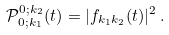Convert formula to latex. <formula><loc_0><loc_0><loc_500><loc_500>\mathcal { P } _ { 0 ; k _ { 1 } } ^ { 0 ; k _ { 2 } } ( t ) = | f _ { k _ { 1 } k _ { 2 } } ( t ) | ^ { 2 } \, .</formula> 